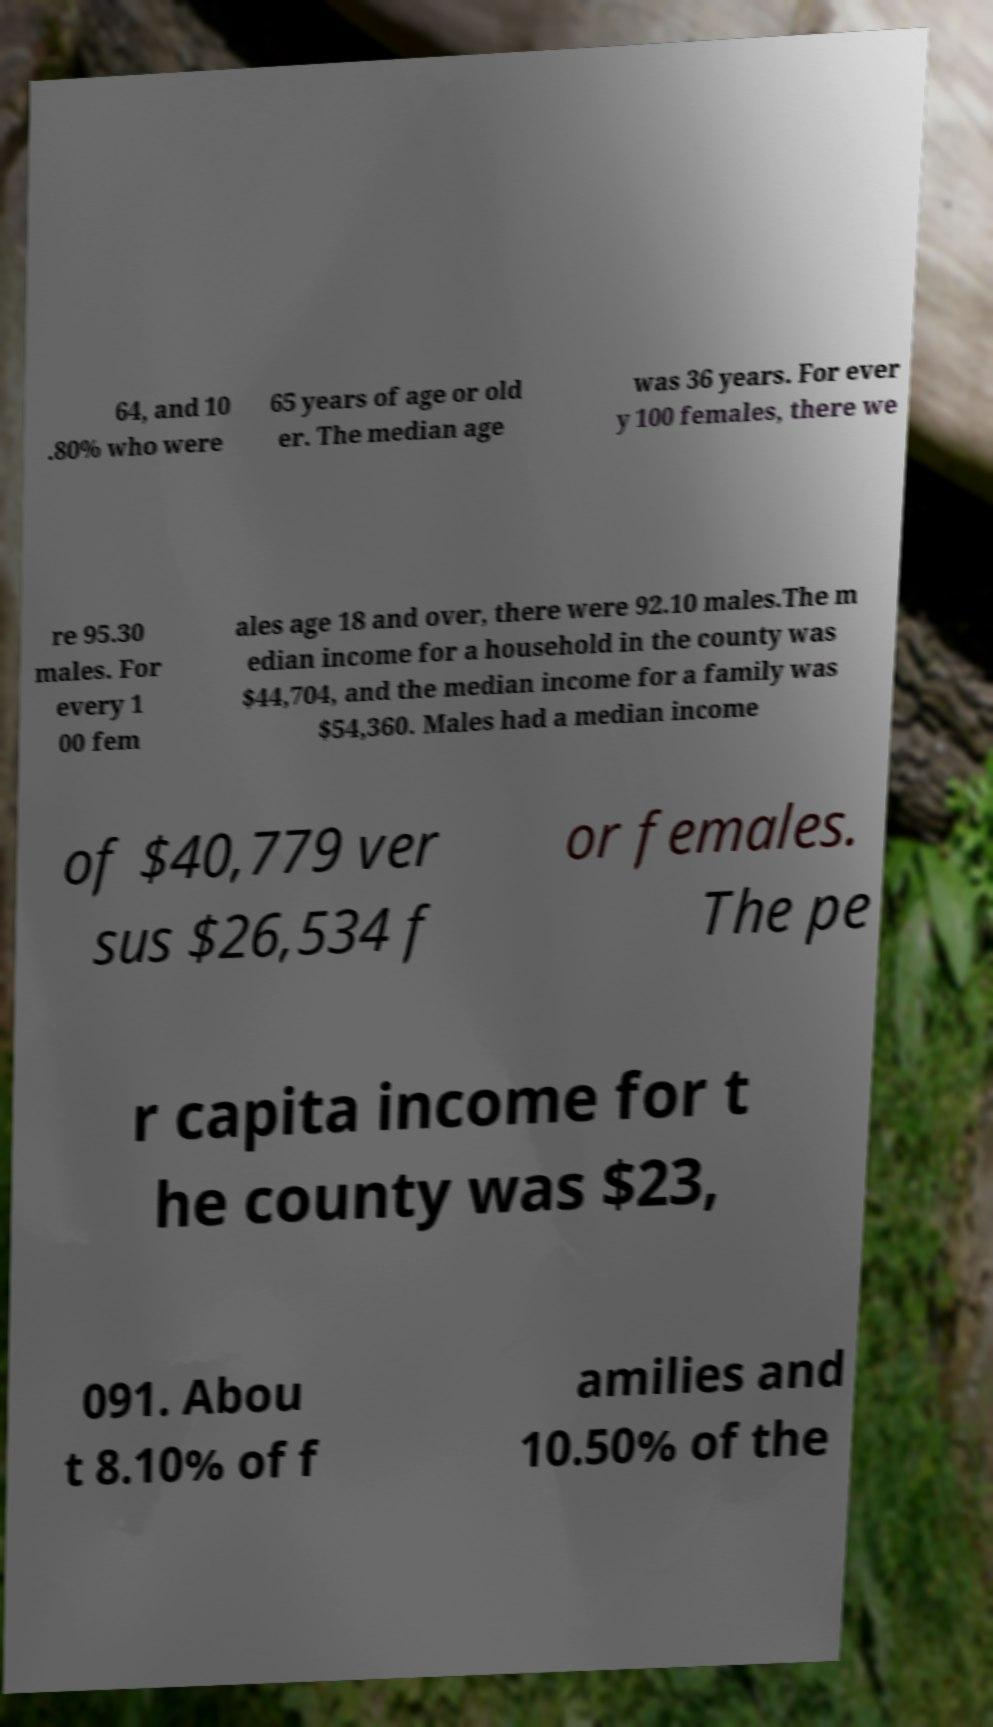I need the written content from this picture converted into text. Can you do that? 64, and 10 .80% who were 65 years of age or old er. The median age was 36 years. For ever y 100 females, there we re 95.30 males. For every 1 00 fem ales age 18 and over, there were 92.10 males.The m edian income for a household in the county was $44,704, and the median income for a family was $54,360. Males had a median income of $40,779 ver sus $26,534 f or females. The pe r capita income for t he county was $23, 091. Abou t 8.10% of f amilies and 10.50% of the 